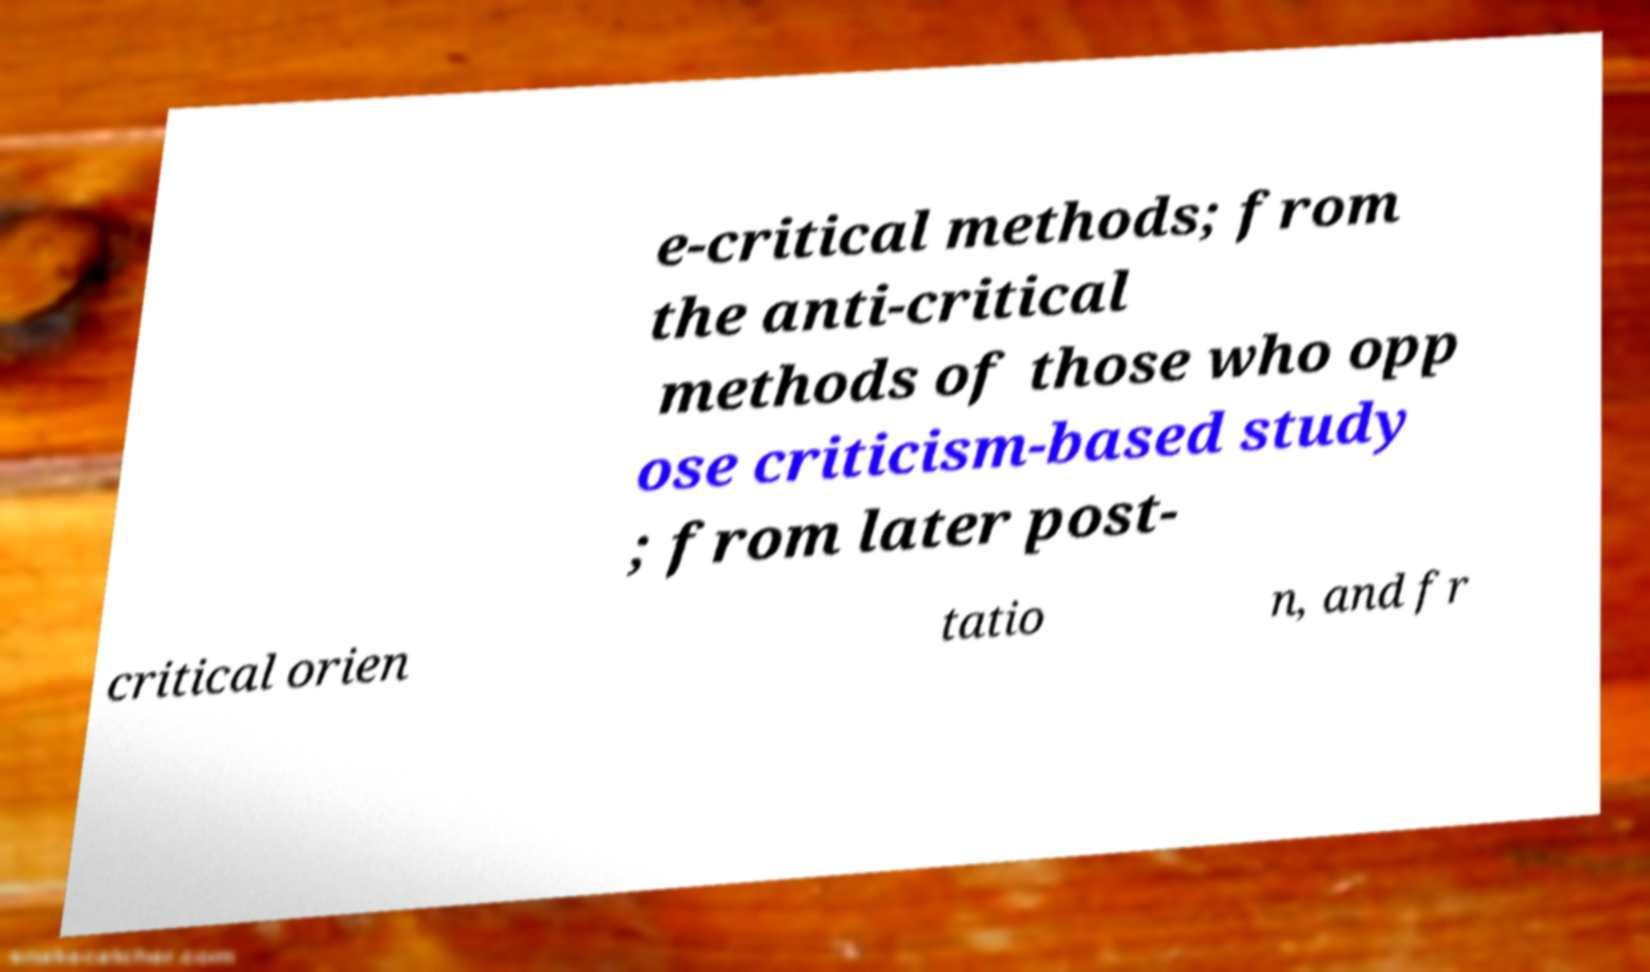I need the written content from this picture converted into text. Can you do that? e-critical methods; from the anti-critical methods of those who opp ose criticism-based study ; from later post- critical orien tatio n, and fr 